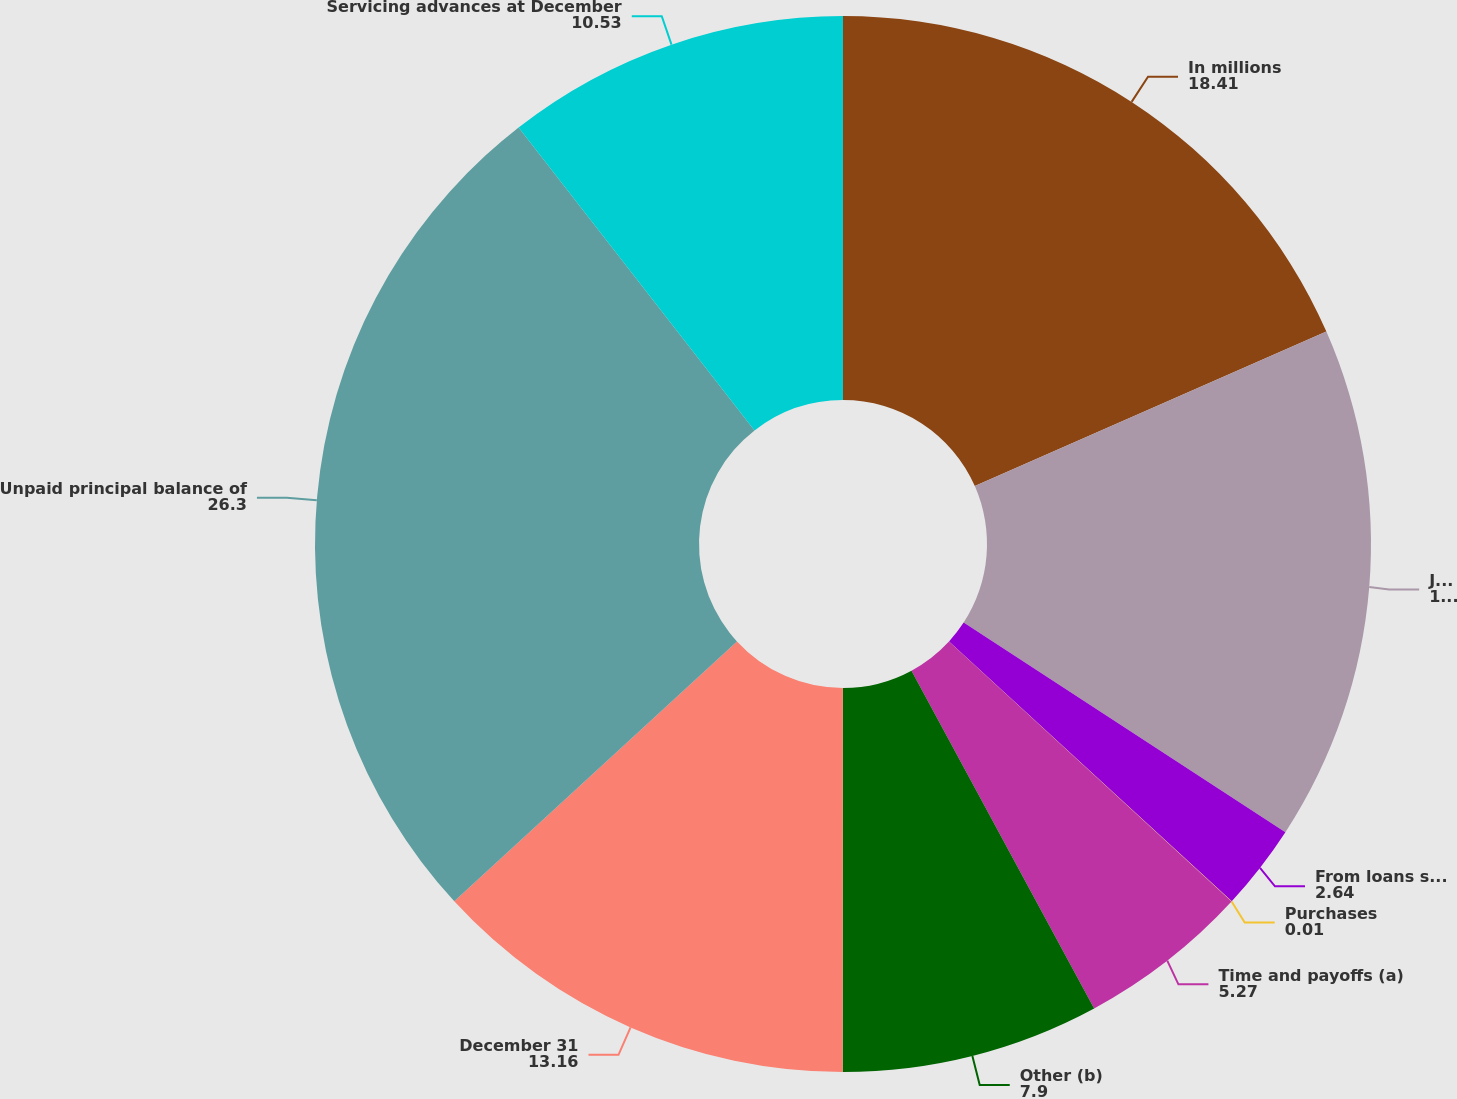Convert chart. <chart><loc_0><loc_0><loc_500><loc_500><pie_chart><fcel>In millions<fcel>January 1<fcel>From loans sold with servicing<fcel>Purchases<fcel>Time and payoffs (a)<fcel>Other (b)<fcel>December 31<fcel>Unpaid principal balance of<fcel>Servicing advances at December<nl><fcel>18.41%<fcel>15.78%<fcel>2.64%<fcel>0.01%<fcel>5.27%<fcel>7.9%<fcel>13.16%<fcel>26.3%<fcel>10.53%<nl></chart> 